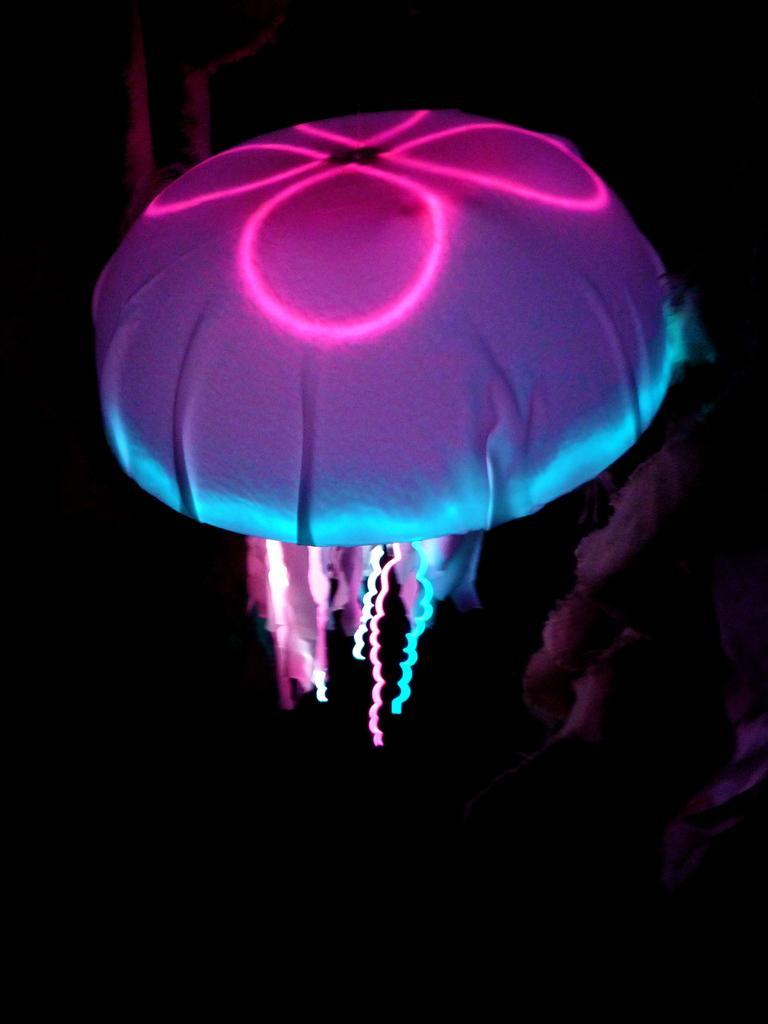Can you describe this image briefly? In this image we can see a jellyfish, here is the light. 